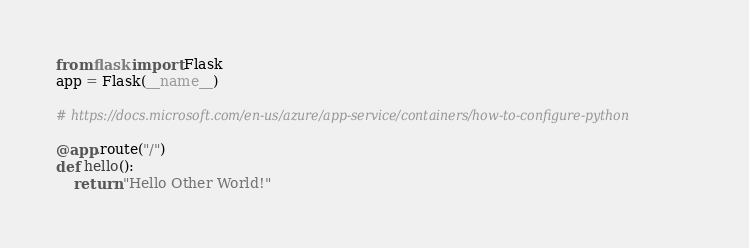<code> <loc_0><loc_0><loc_500><loc_500><_Python_>from flask import Flask
app = Flask(__name__)

# https://docs.microsoft.com/en-us/azure/app-service/containers/how-to-configure-python

@app.route("/")
def hello():
    return "Hello Other World!"</code> 